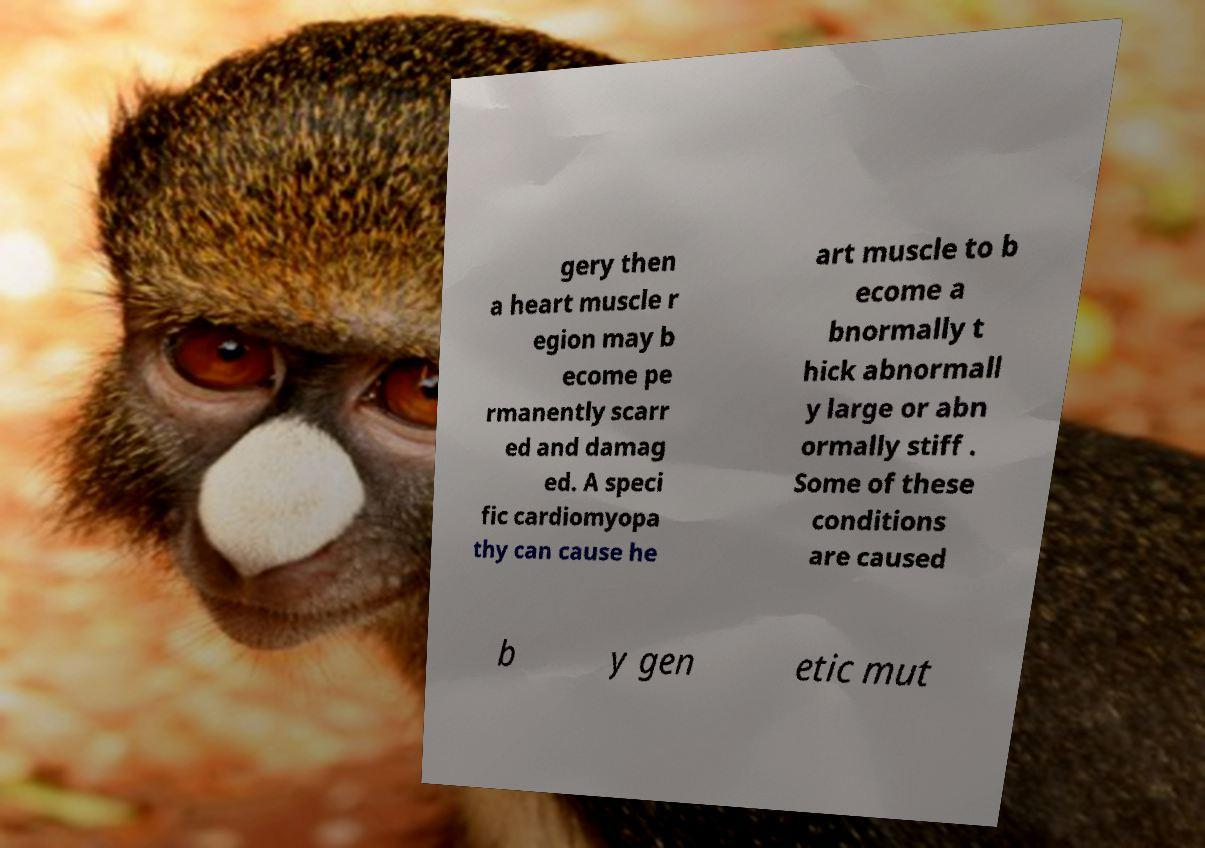Can you accurately transcribe the text from the provided image for me? gery then a heart muscle r egion may b ecome pe rmanently scarr ed and damag ed. A speci fic cardiomyopa thy can cause he art muscle to b ecome a bnormally t hick abnormall y large or abn ormally stiff . Some of these conditions are caused b y gen etic mut 